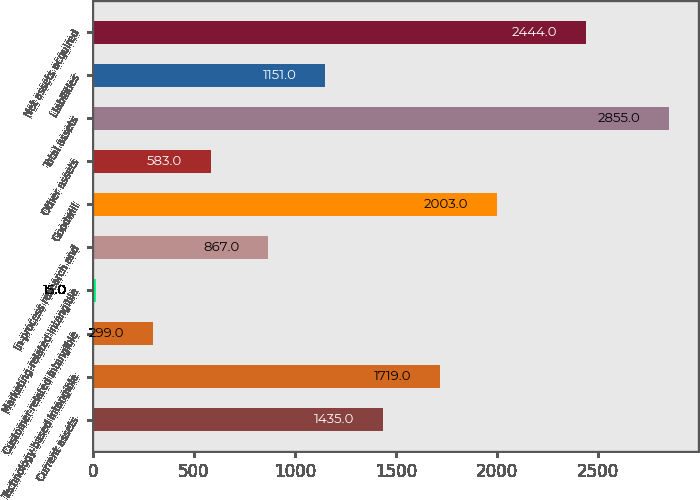Convert chart to OTSL. <chart><loc_0><loc_0><loc_500><loc_500><bar_chart><fcel>Current assets<fcel>Technology-based intangible<fcel>Customer-related intangible<fcel>Marketing-related intangible<fcel>In-process research and<fcel>Goodwill<fcel>Other assets<fcel>Total assets<fcel>Liabilities<fcel>Net assets acquired<nl><fcel>1435<fcel>1719<fcel>299<fcel>15<fcel>867<fcel>2003<fcel>583<fcel>2855<fcel>1151<fcel>2444<nl></chart> 